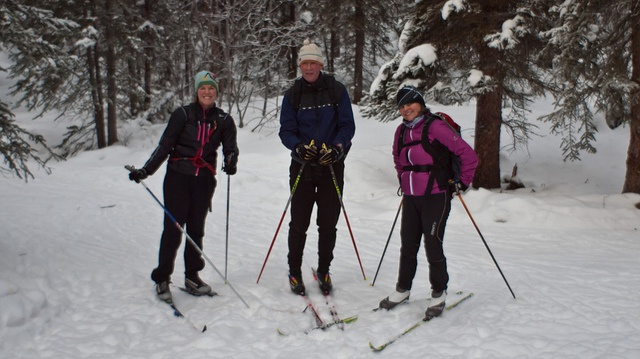Describe the objects in this image and their specific colors. I can see people in black, purple, and darkgray tones, people in black, gray, darkgray, and maroon tones, people in black, gray, maroon, and darkgray tones, skis in black, darkgray, gray, and olive tones, and skis in black, darkgray, and gray tones in this image. 